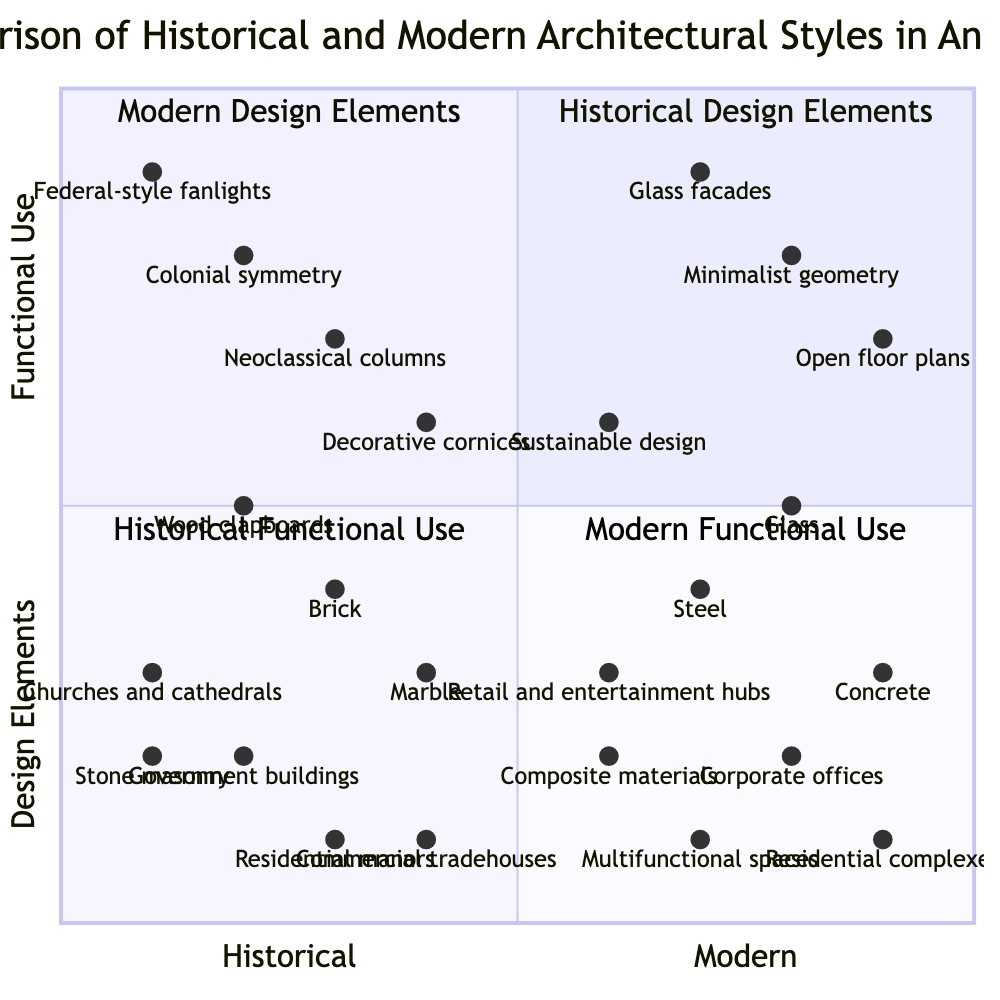What are the key historical design elements represented in the diagram? The diagram lists four key historical design elements in the first quadrant, which are Colonial symmetry, Neoclassical columns, Federal-style fanlights, and Decorative cornices.
Answer: Colonial symmetry, Neoclassical columns, Federal-style fanlights, Decorative cornices Which modern building material is positioned highest on the chart? Looking at the y-axis where functional use is measured, the highest point for modern building materials is represented by Glass, with a point at (0.8, 0.5).
Answer: Glass How many historical functional uses are displayed in the diagram? The historical functional use quadrant contains four distinct uses, which are Residential manors, Government buildings, Churches and cathedrals, and Commercial tradehouses.
Answer: 4 Which architectural style has more contemporary design elements, and what are they? The modern architectural elements listed in the second quadrant showcase minimalism, including Minimalist geometry, Open floor plans, Glass facades, and Sustainable design. This indicates a modernity that is more pronounced compared to historical styles.
Answer: Minimalist geometry, Open floor plans, Glass facades, Sustainable design Which historical building material is closest to the functional use of residential manors? In the quadrant comparing historical building materials with functional uses, Wood clapboards is positioned near the functional use of Residential manors at (0.2, 0.5). This suggests a direct relationship between the material and the use.
Answer: Wood clapboards What is a significant difference in color schemes between historical and modern styles? The historical color schemes lean towards soft and natural tones, like Earth tones and Whitewashed exteriors, whereas modern color schemes are characterized by Monochromatic palettes and Bold accent colors, indicating a shift from muted to more vibrant choices.
Answer: Bold accent colors Which modern functional use aligns with multifunctional spaces? The quadrant for modern functional use includes Multifunctional spaces, Corporate offices, Residential complexes, and Retail and entertainment hubs, positioning Multifunctional spaces as a pivotal contemporary use for adaptability in design.
Answer: Multifunctional spaces How does the position of Decorative cornices compare with Sustainable design? The Decorative cornices are positioned at (0.4, 0.6), while Sustainable design is at (0.6, 0.6). Both share the same y-coordinate, implying they are similarly viewed in terms of functional use, while Sustainable design is more to the right, indicating a modern influence.
Answer: To the right, similar y-coordinate 